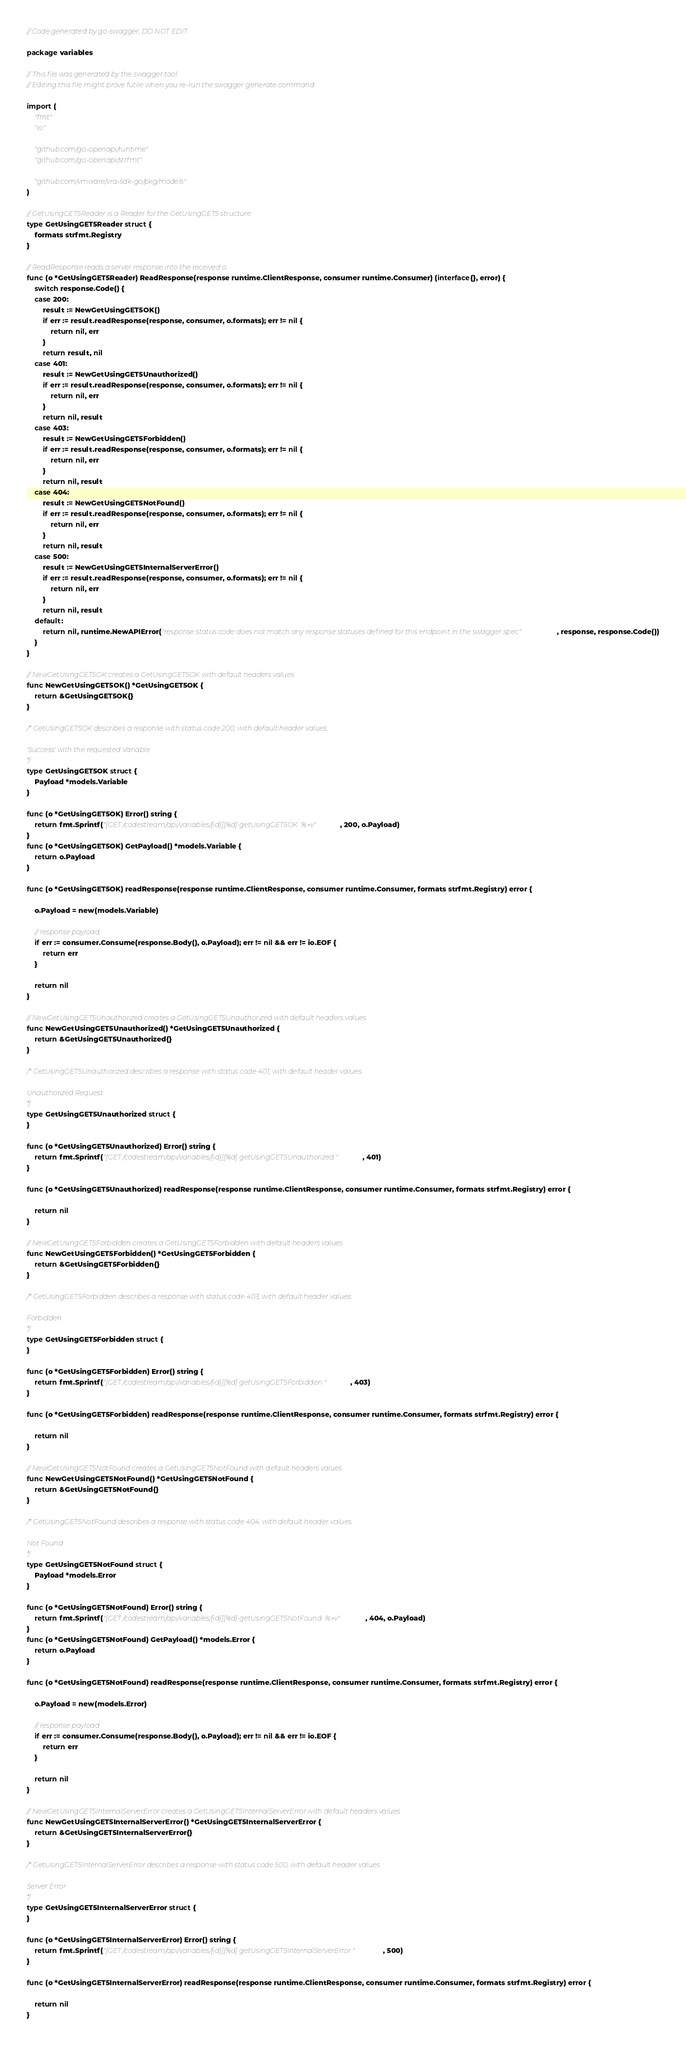Convert code to text. <code><loc_0><loc_0><loc_500><loc_500><_Go_>// Code generated by go-swagger; DO NOT EDIT.

package variables

// This file was generated by the swagger tool.
// Editing this file might prove futile when you re-run the swagger generate command

import (
	"fmt"
	"io"

	"github.com/go-openapi/runtime"
	"github.com/go-openapi/strfmt"

	"github.com/vmware/vra-sdk-go/pkg/models"
)

// GetUsingGET5Reader is a Reader for the GetUsingGET5 structure.
type GetUsingGET5Reader struct {
	formats strfmt.Registry
}

// ReadResponse reads a server response into the received o.
func (o *GetUsingGET5Reader) ReadResponse(response runtime.ClientResponse, consumer runtime.Consumer) (interface{}, error) {
	switch response.Code() {
	case 200:
		result := NewGetUsingGET5OK()
		if err := result.readResponse(response, consumer, o.formats); err != nil {
			return nil, err
		}
		return result, nil
	case 401:
		result := NewGetUsingGET5Unauthorized()
		if err := result.readResponse(response, consumer, o.formats); err != nil {
			return nil, err
		}
		return nil, result
	case 403:
		result := NewGetUsingGET5Forbidden()
		if err := result.readResponse(response, consumer, o.formats); err != nil {
			return nil, err
		}
		return nil, result
	case 404:
		result := NewGetUsingGET5NotFound()
		if err := result.readResponse(response, consumer, o.formats); err != nil {
			return nil, err
		}
		return nil, result
	case 500:
		result := NewGetUsingGET5InternalServerError()
		if err := result.readResponse(response, consumer, o.formats); err != nil {
			return nil, err
		}
		return nil, result
	default:
		return nil, runtime.NewAPIError("response status code does not match any response statuses defined for this endpoint in the swagger spec", response, response.Code())
	}
}

// NewGetUsingGET5OK creates a GetUsingGET5OK with default headers values
func NewGetUsingGET5OK() *GetUsingGET5OK {
	return &GetUsingGET5OK{}
}

/* GetUsingGET5OK describes a response with status code 200, with default header values.

'Success' with the requested Variable
*/
type GetUsingGET5OK struct {
	Payload *models.Variable
}

func (o *GetUsingGET5OK) Error() string {
	return fmt.Sprintf("[GET /codestream/api/variables/{id}][%d] getUsingGET5OK  %+v", 200, o.Payload)
}
func (o *GetUsingGET5OK) GetPayload() *models.Variable {
	return o.Payload
}

func (o *GetUsingGET5OK) readResponse(response runtime.ClientResponse, consumer runtime.Consumer, formats strfmt.Registry) error {

	o.Payload = new(models.Variable)

	// response payload
	if err := consumer.Consume(response.Body(), o.Payload); err != nil && err != io.EOF {
		return err
	}

	return nil
}

// NewGetUsingGET5Unauthorized creates a GetUsingGET5Unauthorized with default headers values
func NewGetUsingGET5Unauthorized() *GetUsingGET5Unauthorized {
	return &GetUsingGET5Unauthorized{}
}

/* GetUsingGET5Unauthorized describes a response with status code 401, with default header values.

Unauthorized Request
*/
type GetUsingGET5Unauthorized struct {
}

func (o *GetUsingGET5Unauthorized) Error() string {
	return fmt.Sprintf("[GET /codestream/api/variables/{id}][%d] getUsingGET5Unauthorized ", 401)
}

func (o *GetUsingGET5Unauthorized) readResponse(response runtime.ClientResponse, consumer runtime.Consumer, formats strfmt.Registry) error {

	return nil
}

// NewGetUsingGET5Forbidden creates a GetUsingGET5Forbidden with default headers values
func NewGetUsingGET5Forbidden() *GetUsingGET5Forbidden {
	return &GetUsingGET5Forbidden{}
}

/* GetUsingGET5Forbidden describes a response with status code 403, with default header values.

Forbidden
*/
type GetUsingGET5Forbidden struct {
}

func (o *GetUsingGET5Forbidden) Error() string {
	return fmt.Sprintf("[GET /codestream/api/variables/{id}][%d] getUsingGET5Forbidden ", 403)
}

func (o *GetUsingGET5Forbidden) readResponse(response runtime.ClientResponse, consumer runtime.Consumer, formats strfmt.Registry) error {

	return nil
}

// NewGetUsingGET5NotFound creates a GetUsingGET5NotFound with default headers values
func NewGetUsingGET5NotFound() *GetUsingGET5NotFound {
	return &GetUsingGET5NotFound{}
}

/* GetUsingGET5NotFound describes a response with status code 404, with default header values.

Not Found
*/
type GetUsingGET5NotFound struct {
	Payload *models.Error
}

func (o *GetUsingGET5NotFound) Error() string {
	return fmt.Sprintf("[GET /codestream/api/variables/{id}][%d] getUsingGET5NotFound  %+v", 404, o.Payload)
}
func (o *GetUsingGET5NotFound) GetPayload() *models.Error {
	return o.Payload
}

func (o *GetUsingGET5NotFound) readResponse(response runtime.ClientResponse, consumer runtime.Consumer, formats strfmt.Registry) error {

	o.Payload = new(models.Error)

	// response payload
	if err := consumer.Consume(response.Body(), o.Payload); err != nil && err != io.EOF {
		return err
	}

	return nil
}

// NewGetUsingGET5InternalServerError creates a GetUsingGET5InternalServerError with default headers values
func NewGetUsingGET5InternalServerError() *GetUsingGET5InternalServerError {
	return &GetUsingGET5InternalServerError{}
}

/* GetUsingGET5InternalServerError describes a response with status code 500, with default header values.

Server Error
*/
type GetUsingGET5InternalServerError struct {
}

func (o *GetUsingGET5InternalServerError) Error() string {
	return fmt.Sprintf("[GET /codestream/api/variables/{id}][%d] getUsingGET5InternalServerError ", 500)
}

func (o *GetUsingGET5InternalServerError) readResponse(response runtime.ClientResponse, consumer runtime.Consumer, formats strfmt.Registry) error {

	return nil
}
</code> 